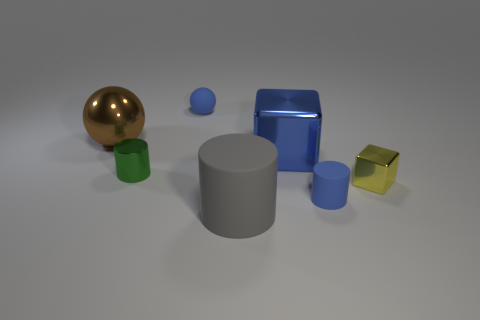What shape is the gray rubber thing?
Ensure brevity in your answer.  Cylinder. Do the tiny blue object in front of the metallic ball and the big object left of the small green thing have the same material?
Ensure brevity in your answer.  No. What number of large shiny blocks are the same color as the tiny matte ball?
Provide a short and direct response. 1. The metal object that is both in front of the big blue block and right of the metallic cylinder has what shape?
Give a very brief answer. Cube. There is a metal object that is both right of the big brown sphere and on the left side of the big gray matte thing; what is its color?
Make the answer very short. Green. Is the number of small objects that are right of the blue metallic block greater than the number of small balls that are left of the tiny green metallic thing?
Your response must be concise. Yes. There is a large thing that is right of the gray matte object; what color is it?
Make the answer very short. Blue. Does the small blue thing that is in front of the big brown sphere have the same shape as the blue rubber object to the left of the blue metallic block?
Give a very brief answer. No. Is there a metal sphere of the same size as the yellow thing?
Your answer should be very brief. No. There is a object left of the metal cylinder; what is it made of?
Give a very brief answer. Metal. 